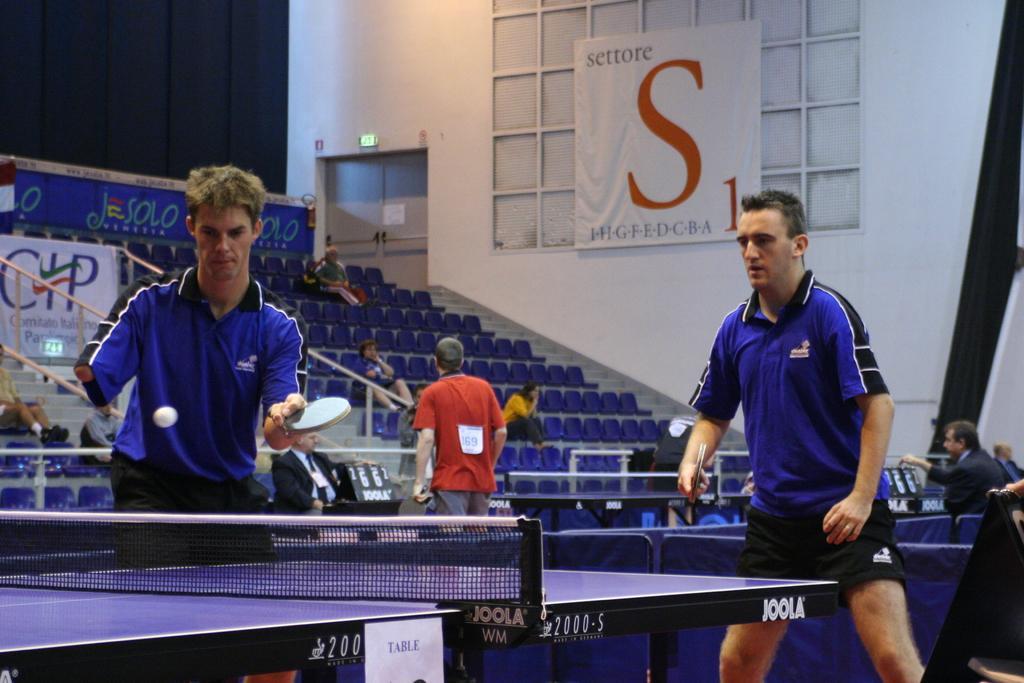Describe this image in one or two sentences. In this image we can see these two persons wearing blue T-shirts are holding rackets in their hands. Here we can see a ball in the air and table tennis table. In the background, we can see these people are in the court and these people are sitting in the stadium. Here we can see the banners, gate and the wall. 